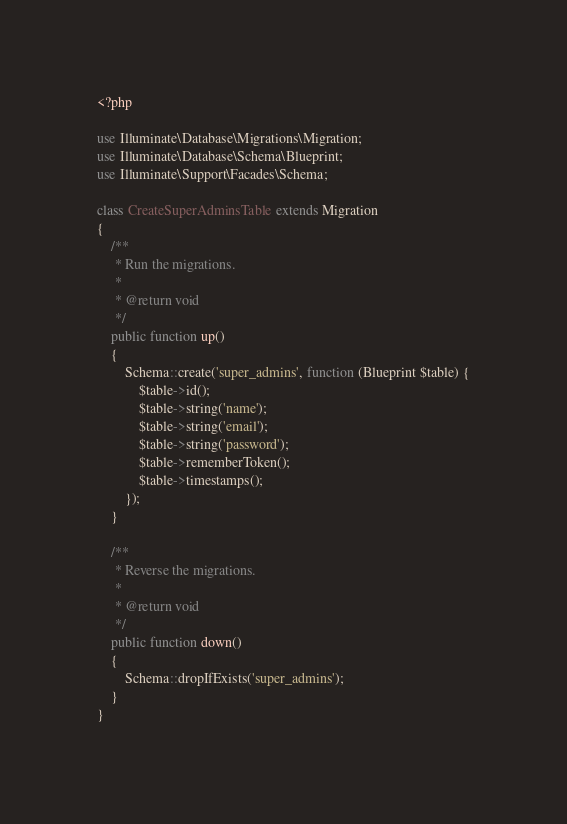Convert code to text. <code><loc_0><loc_0><loc_500><loc_500><_PHP_><?php

use Illuminate\Database\Migrations\Migration;
use Illuminate\Database\Schema\Blueprint;
use Illuminate\Support\Facades\Schema;

class CreateSuperAdminsTable extends Migration
{
    /**
     * Run the migrations.
     *
     * @return void
     */
    public function up()
    {
        Schema::create('super_admins', function (Blueprint $table) {
            $table->id();
            $table->string('name');
            $table->string('email');
            $table->string('password');
            $table->rememberToken();
            $table->timestamps();
        });
    }

    /**
     * Reverse the migrations.
     *
     * @return void
     */
    public function down()
    {
        Schema::dropIfExists('super_admins');
    }
}
</code> 